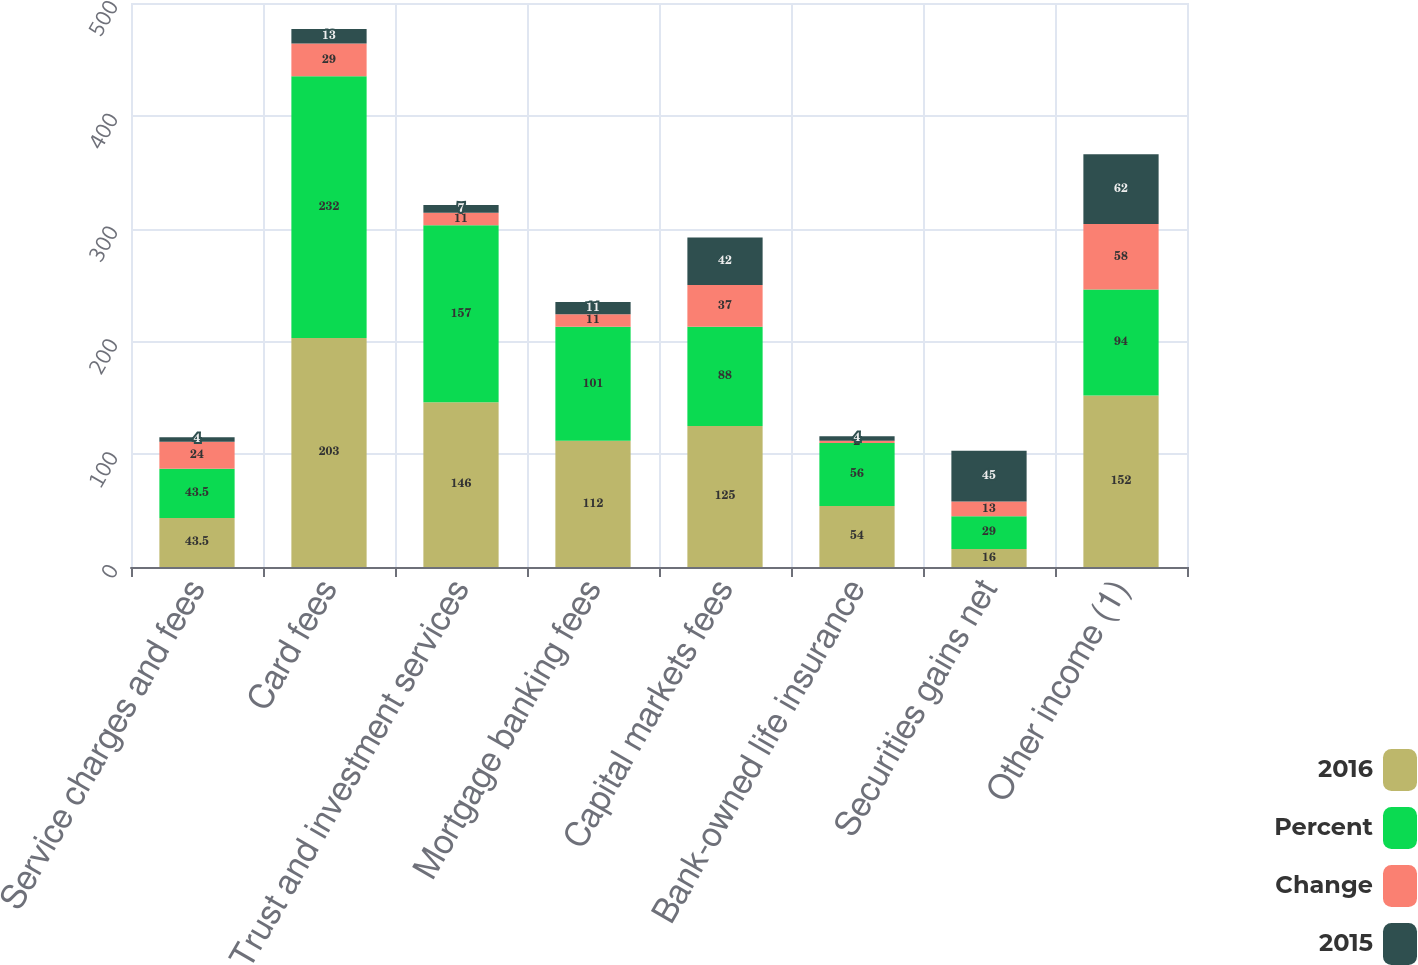<chart> <loc_0><loc_0><loc_500><loc_500><stacked_bar_chart><ecel><fcel>Service charges and fees<fcel>Card fees<fcel>Trust and investment services<fcel>Mortgage banking fees<fcel>Capital markets fees<fcel>Bank-owned life insurance<fcel>Securities gains net<fcel>Other income (1)<nl><fcel>2016<fcel>43.5<fcel>203<fcel>146<fcel>112<fcel>125<fcel>54<fcel>16<fcel>152<nl><fcel>Percent<fcel>43.5<fcel>232<fcel>157<fcel>101<fcel>88<fcel>56<fcel>29<fcel>94<nl><fcel>Change<fcel>24<fcel>29<fcel>11<fcel>11<fcel>37<fcel>2<fcel>13<fcel>58<nl><fcel>2015<fcel>4<fcel>13<fcel>7<fcel>11<fcel>42<fcel>4<fcel>45<fcel>62<nl></chart> 